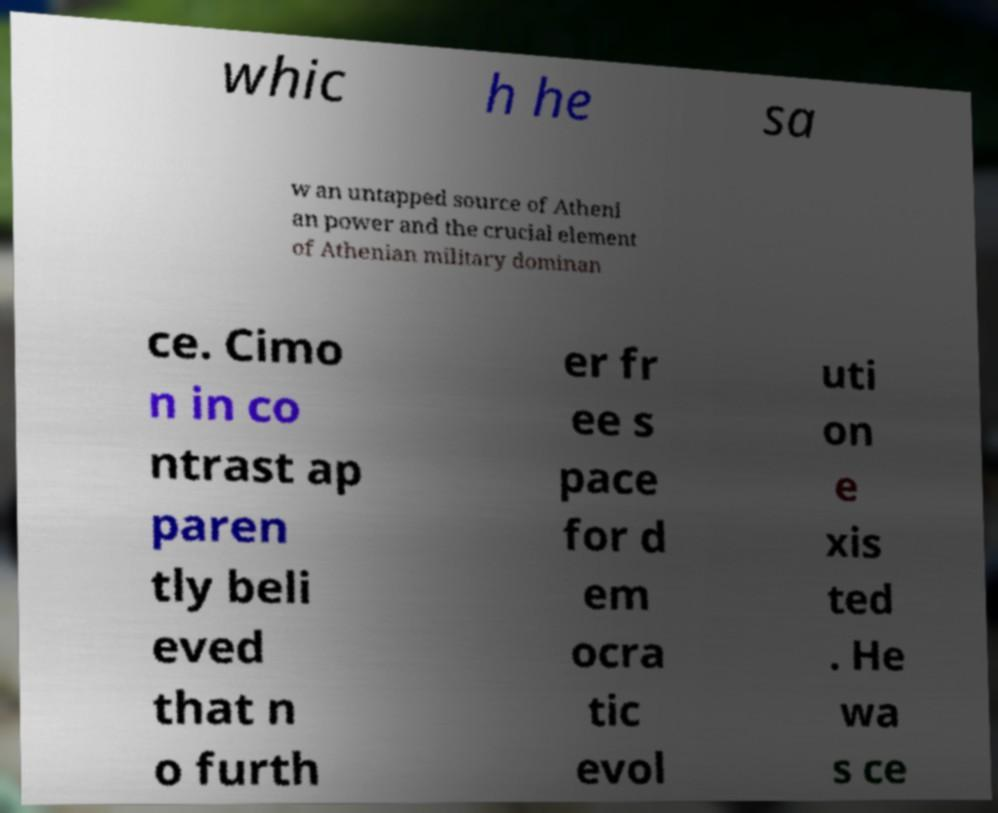I need the written content from this picture converted into text. Can you do that? whic h he sa w an untapped source of Atheni an power and the crucial element of Athenian military dominan ce. Cimo n in co ntrast ap paren tly beli eved that n o furth er fr ee s pace for d em ocra tic evol uti on e xis ted . He wa s ce 